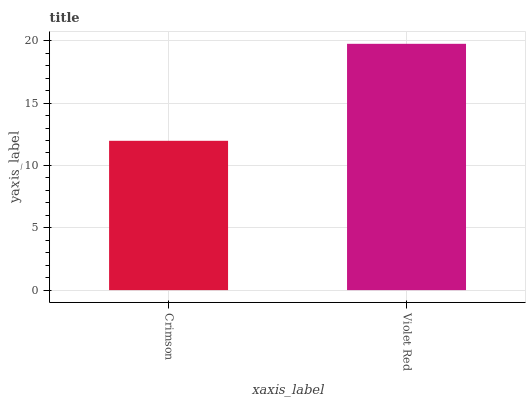Is Crimson the minimum?
Answer yes or no. Yes. Is Violet Red the maximum?
Answer yes or no. Yes. Is Violet Red the minimum?
Answer yes or no. No. Is Violet Red greater than Crimson?
Answer yes or no. Yes. Is Crimson less than Violet Red?
Answer yes or no. Yes. Is Crimson greater than Violet Red?
Answer yes or no. No. Is Violet Red less than Crimson?
Answer yes or no. No. Is Violet Red the high median?
Answer yes or no. Yes. Is Crimson the low median?
Answer yes or no. Yes. Is Crimson the high median?
Answer yes or no. No. Is Violet Red the low median?
Answer yes or no. No. 